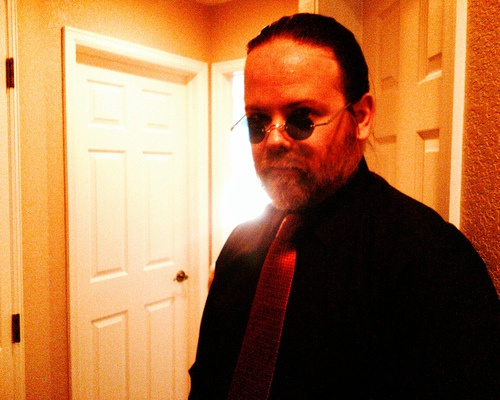Describe the objects in this image and their specific colors. I can see people in tan, black, maroon, red, and brown tones and tie in tan, black, maroon, and red tones in this image. 